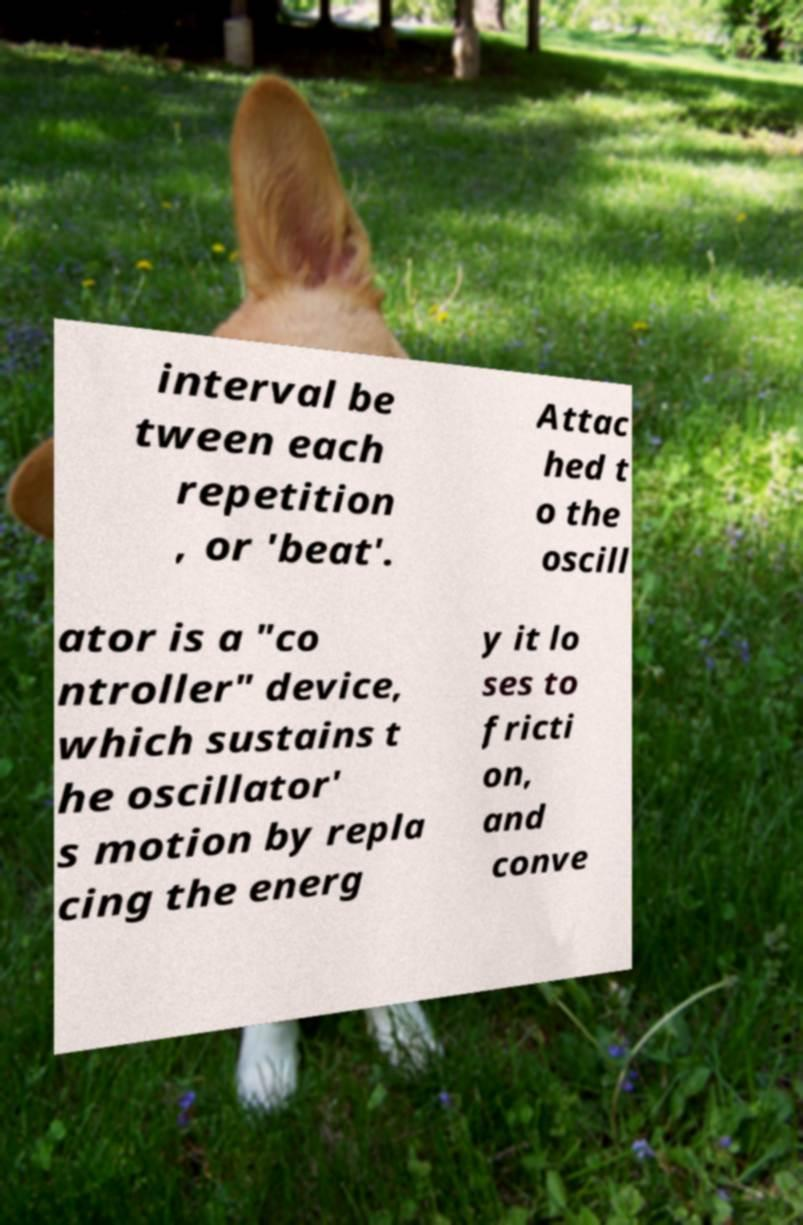Can you read and provide the text displayed in the image?This photo seems to have some interesting text. Can you extract and type it out for me? interval be tween each repetition , or 'beat'. Attac hed t o the oscill ator is a "co ntroller" device, which sustains t he oscillator' s motion by repla cing the energ y it lo ses to fricti on, and conve 